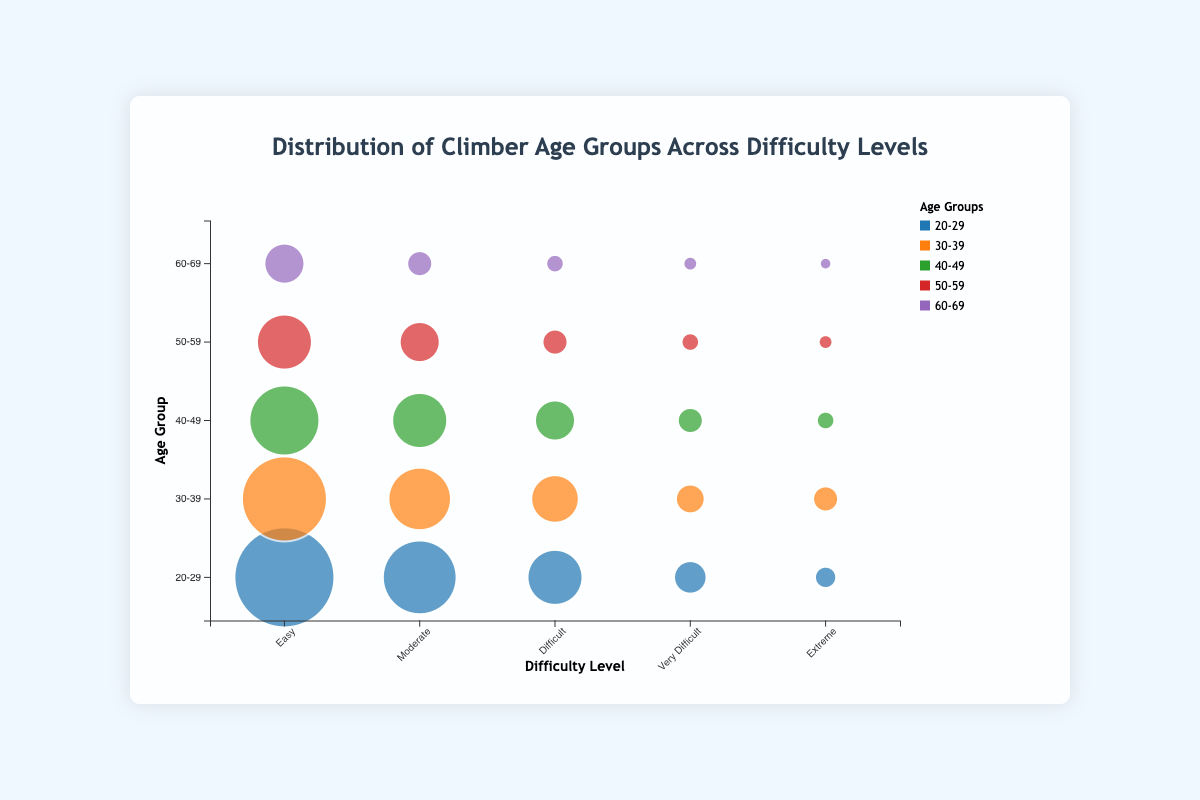What is the title of the chart? The title of the chart is prominently displayed at the top of the chart area.
Answer: Distribution of Climber Age Groups Across Difficulty Levels How many age groups are displayed in the chart? The chart has different colored bubbles for each age group represented in the legend. Counting the colors or reading the labels in the legend gives the total number of age groups.
Answer: 5 Which difficulty level has the highest number of climbers aged 20-29? By observing the bubble size for the age group 20-29 across the difficulty levels, the largest bubble indicates the highest number. The 'Easy' difficulty level has the largest bubble.
Answer: Easy Compare the number of climbers in the 30-39 age group at the 'Very Difficult' and 'Extreme' difficulty levels. Which is greater? Measure the bubbles' size or check the legend information to find that 'Very Difficult' has 25 climbers while 'Extreme' has 20 climbers in the 30-39 age group. Therefore, 'Very Difficult' is greater.
Answer: Very Difficult What is the total number of climbers for the age group 50-59 across all difficulty levels? Sum the number of climbers in each difficulty level for the age group 50-59 by adding 60 (Easy), 40 (Moderate), 20 (Difficult), 10 (Very Difficult), and 5 (Extreme).
Answer: 135 Which age group has the smallest bubble for the 'Extreme' difficulty level? By comparing the bubbles for the 'Extreme' difficulty level across all age groups, the age group 60-69 has the smallest bubble.
Answer: 60-69 How does the number of climbers aged 40-49 at 'Moderate' difficulty compare to those aged 60-69 at 'Moderate' difficulty? Compare the bubble sizes or refer to the numbers: 60 climbers for 40-49 and 20 climbers for 60-69 at 'Moderate' difficulty. The number for 40-49 is greater.
Answer: Greater What is the difference in the number of climbers between the age groups 20-29 and 30-39 at the 'Difficult' difficulty level? Subtract the number of climbers in the 30-39 age group from the number in the 20-29 age group at the 'Difficult' level: 60 - 50 = 10.
Answer: 10 Which age group has the highest bubble transparency at 'Easy' difficulty and why? As the bubble transparency is likely uniform and not specified to differ in the data, the question focuses on visual appearance. All age groups have the same transparency level due to uniform style.
Answer: All age groups have the same transparency Compare the difficulty levels of 'Very Difficult' and 'Difficult' for the age group 60-69. Which has more climbers? The bubble for 'Very Difficult' is observed to be smaller than that for 'Difficult' in the 60-69 age group. 'Difficult' has more climbers.
Answer: Difficult 